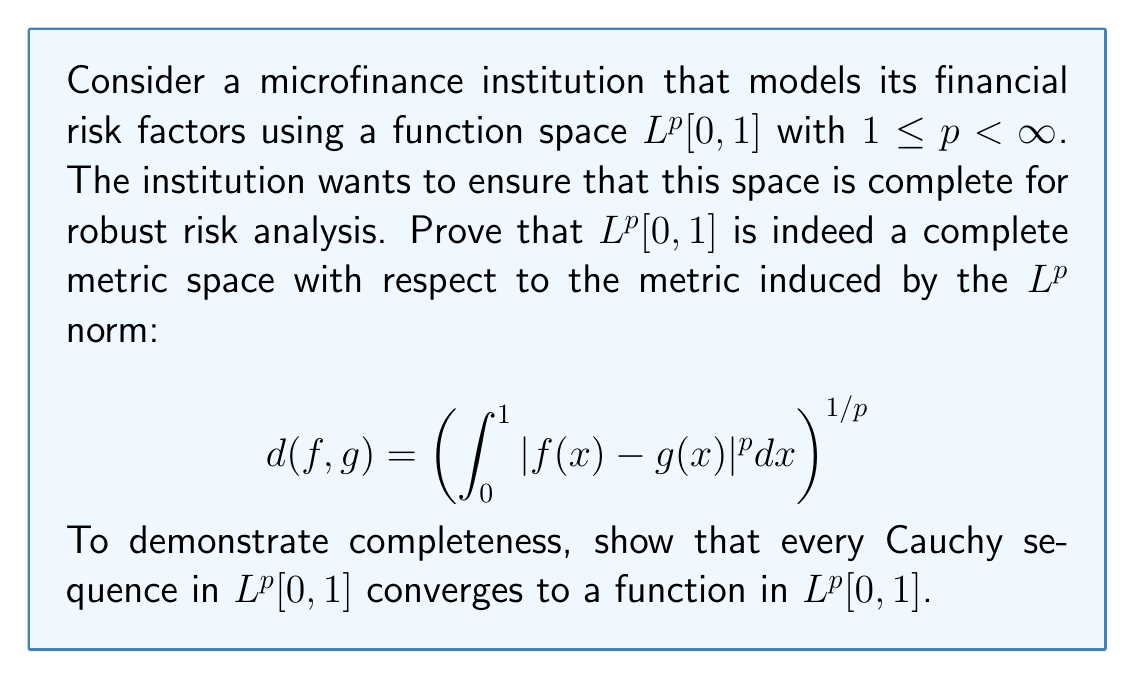Can you answer this question? To prove that $L^p[0,1]$ is complete, we need to show that every Cauchy sequence in this space converges to a function within the same space. Let's proceed step by step:

1) Let $(f_n)$ be a Cauchy sequence in $L^p[0,1]$. This means that for any $\epsilon > 0$, there exists an $N \in \mathbb{N}$ such that for all $m,n \geq N$:

   $$\left(\int_0^1 |f_m(x) - f_n(x)|^p dx\right)^{1/p} < \epsilon$$

2) We need to show that there exists a function $f \in L^p[0,1]$ such that $f_n \to f$ in the $L^p$ norm.

3) First, we can extract a subsequence $(f_{n_k})$ such that:

   $$\left(\int_0^1 |f_{n_{k+1}}(x) - f_{n_k}(x)|^p dx\right)^{1/p} < 2^{-k}$$

4) Define a new sequence of functions:

   $$g_k(x) = |f_{n_{k+1}}(x) - f_{n_k}(x)|$$

5) Now, consider the series $\sum_{k=1}^{\infty} g_k(x)$. We can show that this series converges almost everywhere and in $L^p[0,1]$ using Minkowski's inequality:

   $$\left(\int_0^1 \left(\sum_{k=1}^{\infty} g_k(x)\right)^p dx\right)^{1/p} \leq \sum_{k=1}^{\infty} \left(\int_0^1 g_k(x)^p dx\right)^{1/p} < \sum_{k=1}^{\infty} 2^{-k} = 1$$

6) This implies that the series $\sum_{k=1}^{\infty} (f_{n_{k+1}}(x) - f_{n_k}(x))$ converges almost everywhere to some function $h(x)$.

7) Define $f(x) = f_{n_1}(x) + h(x)$. We can show that $f \in L^p[0,1]$ and $f_{n_k} \to f$ in $L^p[0,1]$.

8) Finally, since $(f_{n_k})$ is a subsequence of the original Cauchy sequence $(f_n)$, we can conclude that $f_n \to f$ in $L^p[0,1]$.

Therefore, every Cauchy sequence in $L^p[0,1]$ converges to a function in $L^p[0,1]$, proving that this space is complete.
Answer: $L^p[0,1]$ is a complete metric space for $1 \leq p < \infty$, as every Cauchy sequence in this space converges to a function within $L^p[0,1]$. 